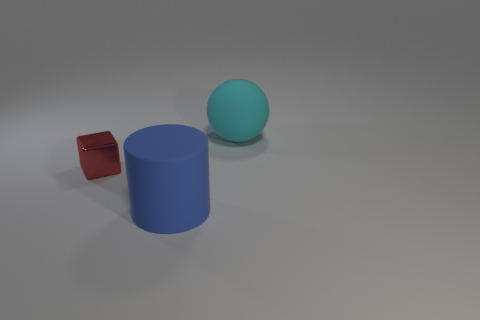There is a big cylinder; is its color the same as the rubber object that is behind the tiny object?
Provide a succinct answer. No. Are there more yellow metal blocks than big matte cylinders?
Your answer should be very brief. No. Are the red block and the large thing behind the large cylinder made of the same material?
Your answer should be very brief. No. What number of things are either tiny green matte blocks or cylinders?
Ensure brevity in your answer.  1. Do the thing that is to the right of the blue matte object and the object that is left of the blue thing have the same size?
Provide a short and direct response. No. What number of balls are small cyan shiny things or tiny metal objects?
Ensure brevity in your answer.  0. Are any red rubber cylinders visible?
Make the answer very short. No. Is there any other thing that is the same shape as the big cyan object?
Provide a succinct answer. No. Is the color of the large rubber ball the same as the metallic object?
Your answer should be very brief. No. What number of objects are either large matte balls on the right side of the matte cylinder or big red metal spheres?
Offer a terse response. 1. 